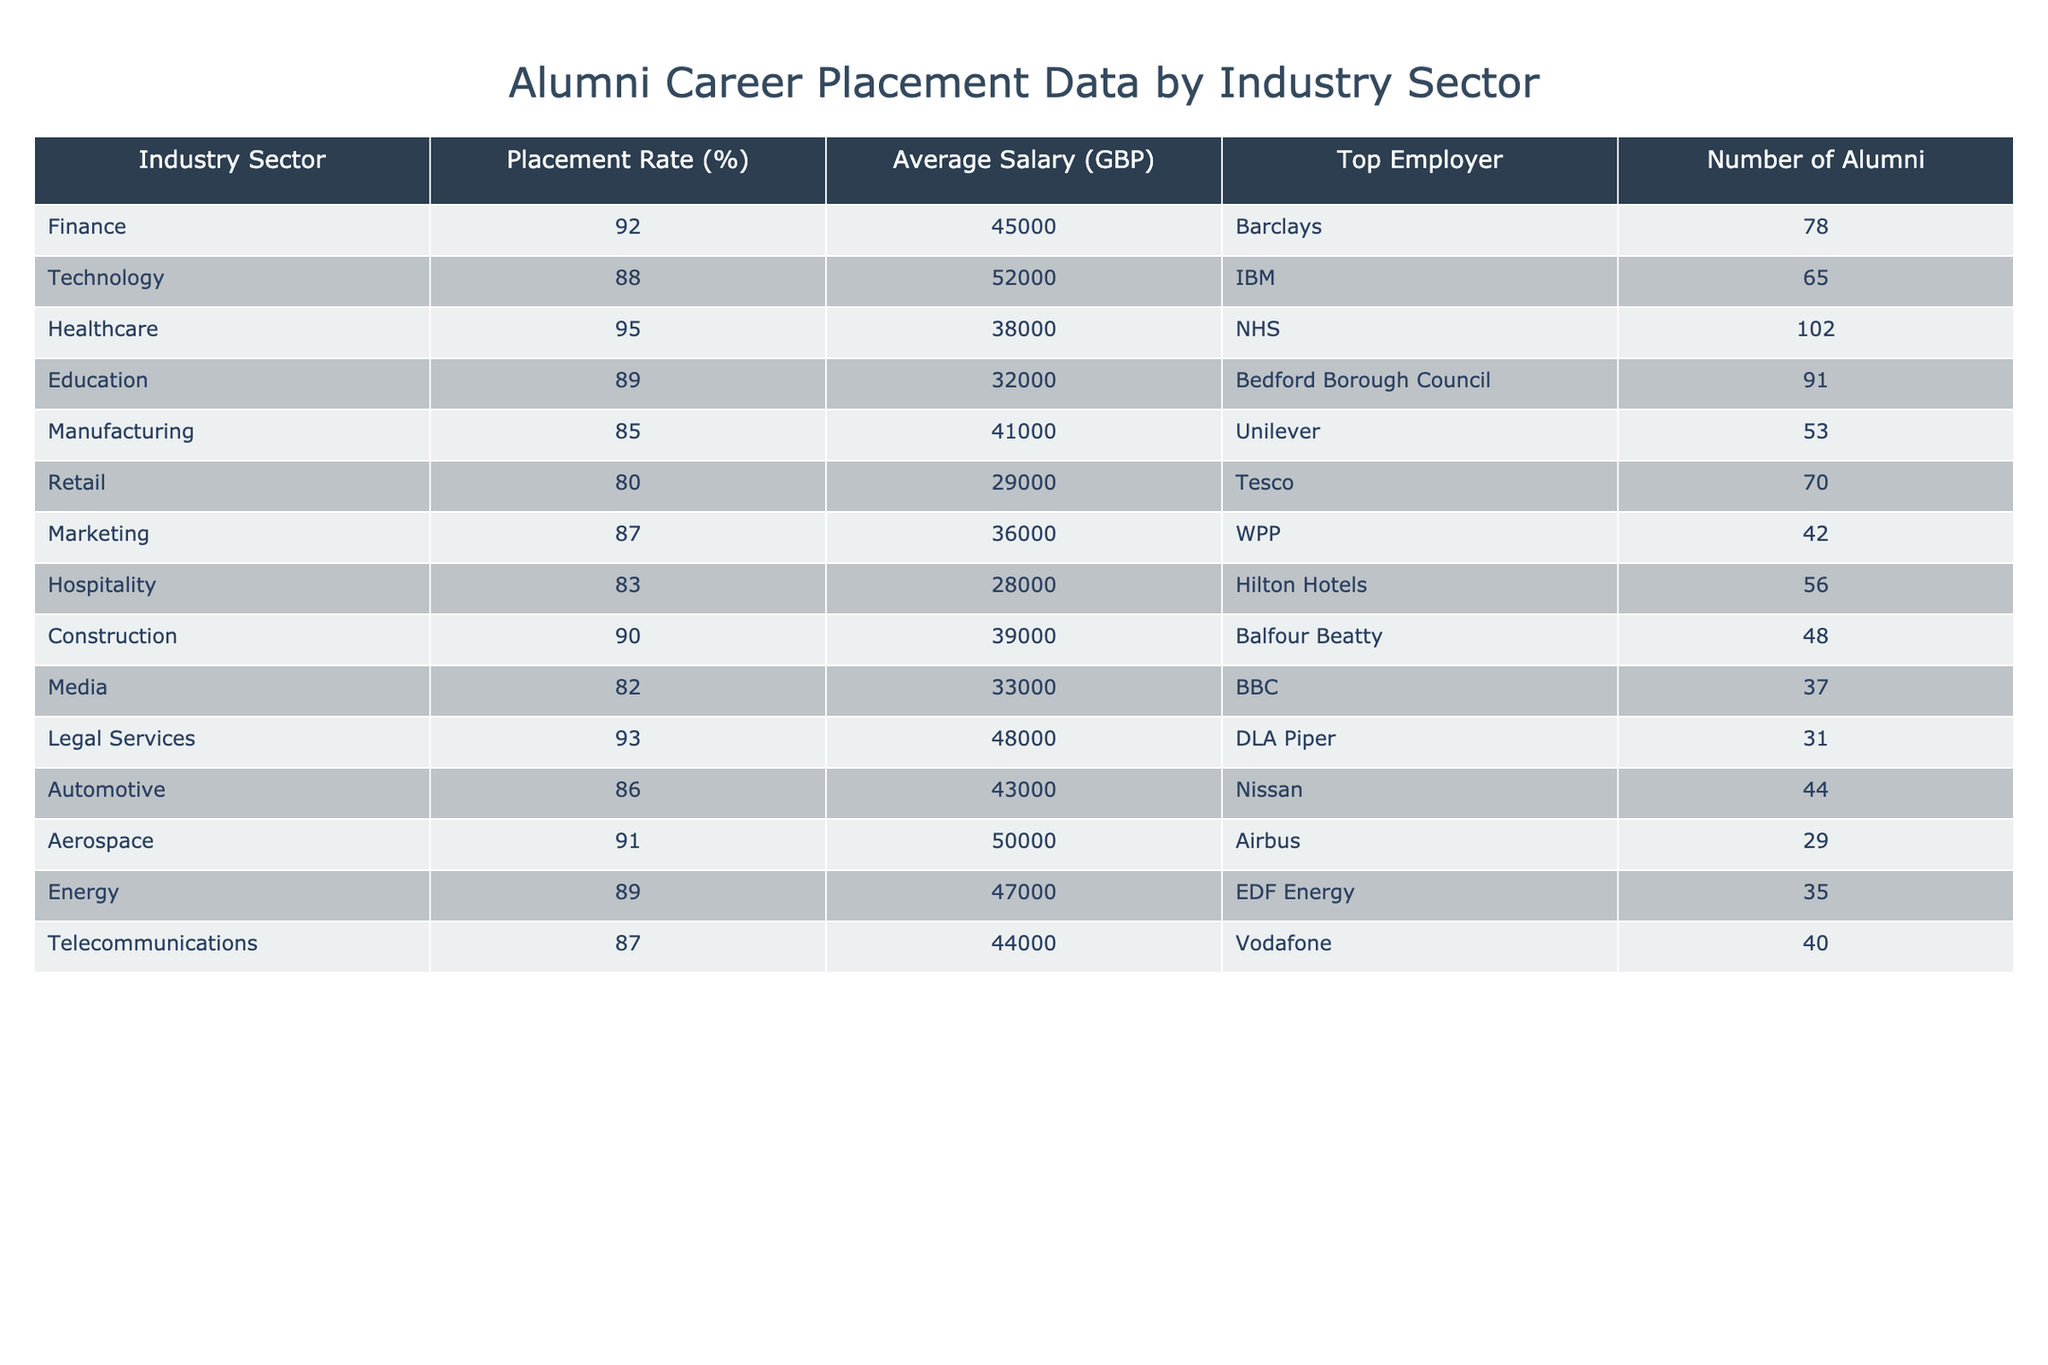What is the placement rate for the Healthcare industry sector? The table shows the placement rate percentage for each industry sector. By looking at the row for Healthcare, it is listed as 95%.
Answer: 95% Which industry has the highest average salary? To find the industry with the highest average salary, we compare the Average Salary (GBP) values across all sectors. The highest value in the table is for Technology at 52,000 GBP.
Answer: Technology How many alumni were placed in the Legal Services sector? The table provides the number of alumni for each sector. In the Legal Services row, it indicates 31 alumni were placed.
Answer: 31 Is the average salary for the Manufacturing sector higher than that of the Retail sector? The average salary for Manufacturing is 41,000 GBP while for Retail it is 29,000 GBP. Since 41,000 is greater than 29,000, the answer is yes.
Answer: Yes What is the total number of alumni across all sectors listed? To find the total number of alumni, we sum the numbers from the "Number of Alumni" column: 78 + 65 + 102 + 91 + 53 + 70 + 42 + 56 + 48 + 37 + 31 + 44 + 29 + 35 + 40 =  882.
Answer: 882 Which sector has the lowest placement rate? Looking at the Placement Rate (%) column, we find that Retail has the lowest rate at 80%.
Answer: Retail If we group the average salaries into two categories: above and below 40,000 GBP, how many sectors fall above 40,000 GBP? We check the Average Salary values: Finance, Technology, Healthcare, Legal Services, Automotive, Aerospace, and Energy all have salaries above 40,000 GBP. This makes for a total of 7 sectors.
Answer: 7 Which sector has the same placement rate as the Marketing sector? The Marketing sector has a placement rate of 87%. We compare this with other sectors, and we find that Telecommunications also has a placement rate of 87%.
Answer: Telecommunications Are there more alumni in the Construction sector than in the Energy sector? The table shows that Construction has 48 alumni and Energy has 35 alumni. Since 48 is greater than 35, the answer is yes.
Answer: Yes What is the average placement rate for the sectors with the highest number of alumni? The highest number of alumni is in Healthcare (102), Education (91), and Finance (78). Thus, the average placement rate is (95 + 89 + 92) / 3 = 92%.
Answer: 92% 